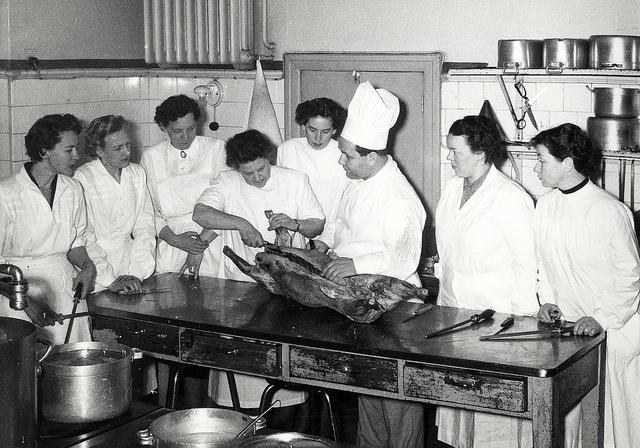How many people are there?
Give a very brief answer. 8. 